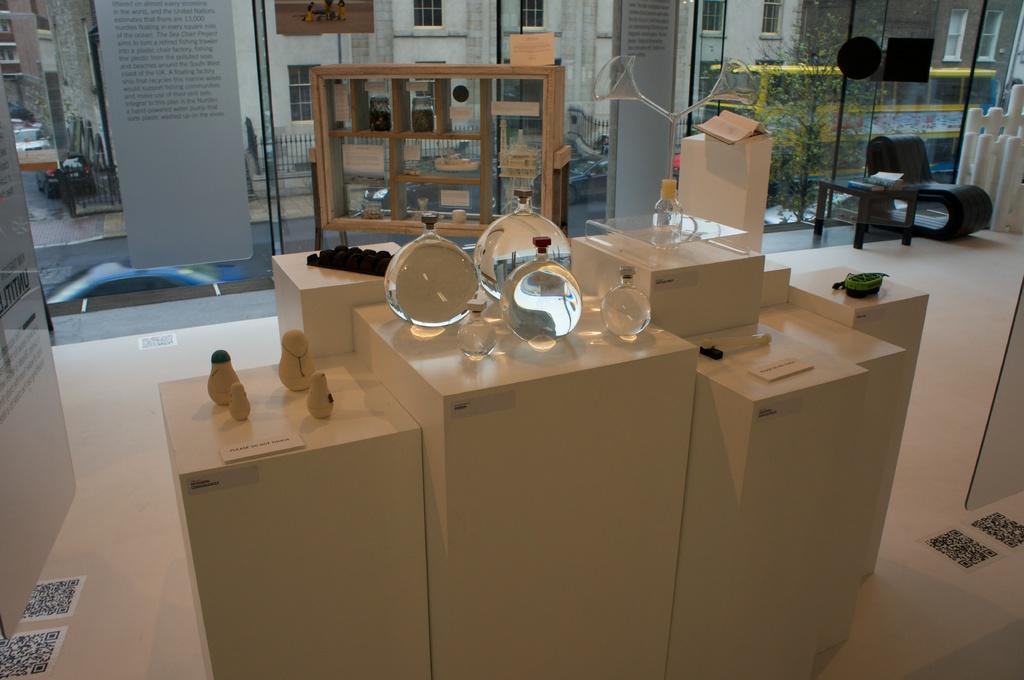Please provide a concise description of this image. In this image, I can see the glass jars and few other objects on the tables. On the left side of the image, I can see a board. On the right side of the image, there is a table with books and a chair. I can see buildings, a tree and vehicles on the road through the glass windows. I can see few other things, which are kept in a cupboard. 